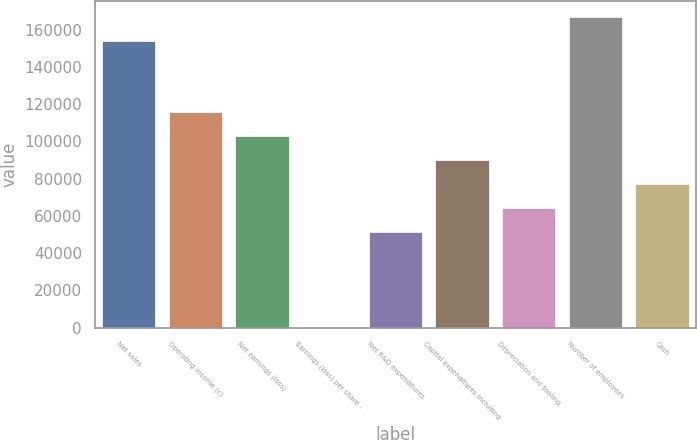Convert chart. <chart><loc_0><loc_0><loc_500><loc_500><bar_chart><fcel>Net sales<fcel>Operating income (c)<fcel>Net earnings (loss)<fcel>Earnings (loss) per share -<fcel>Net R&D expenditures<fcel>Capital expenditures including<fcel>Depreciation and tooling<fcel>Number of employees<fcel>Cash<nl><fcel>154161<fcel>115622<fcel>102775<fcel>4.45<fcel>51389.9<fcel>89929<fcel>64236.2<fcel>167007<fcel>77082.6<nl></chart> 